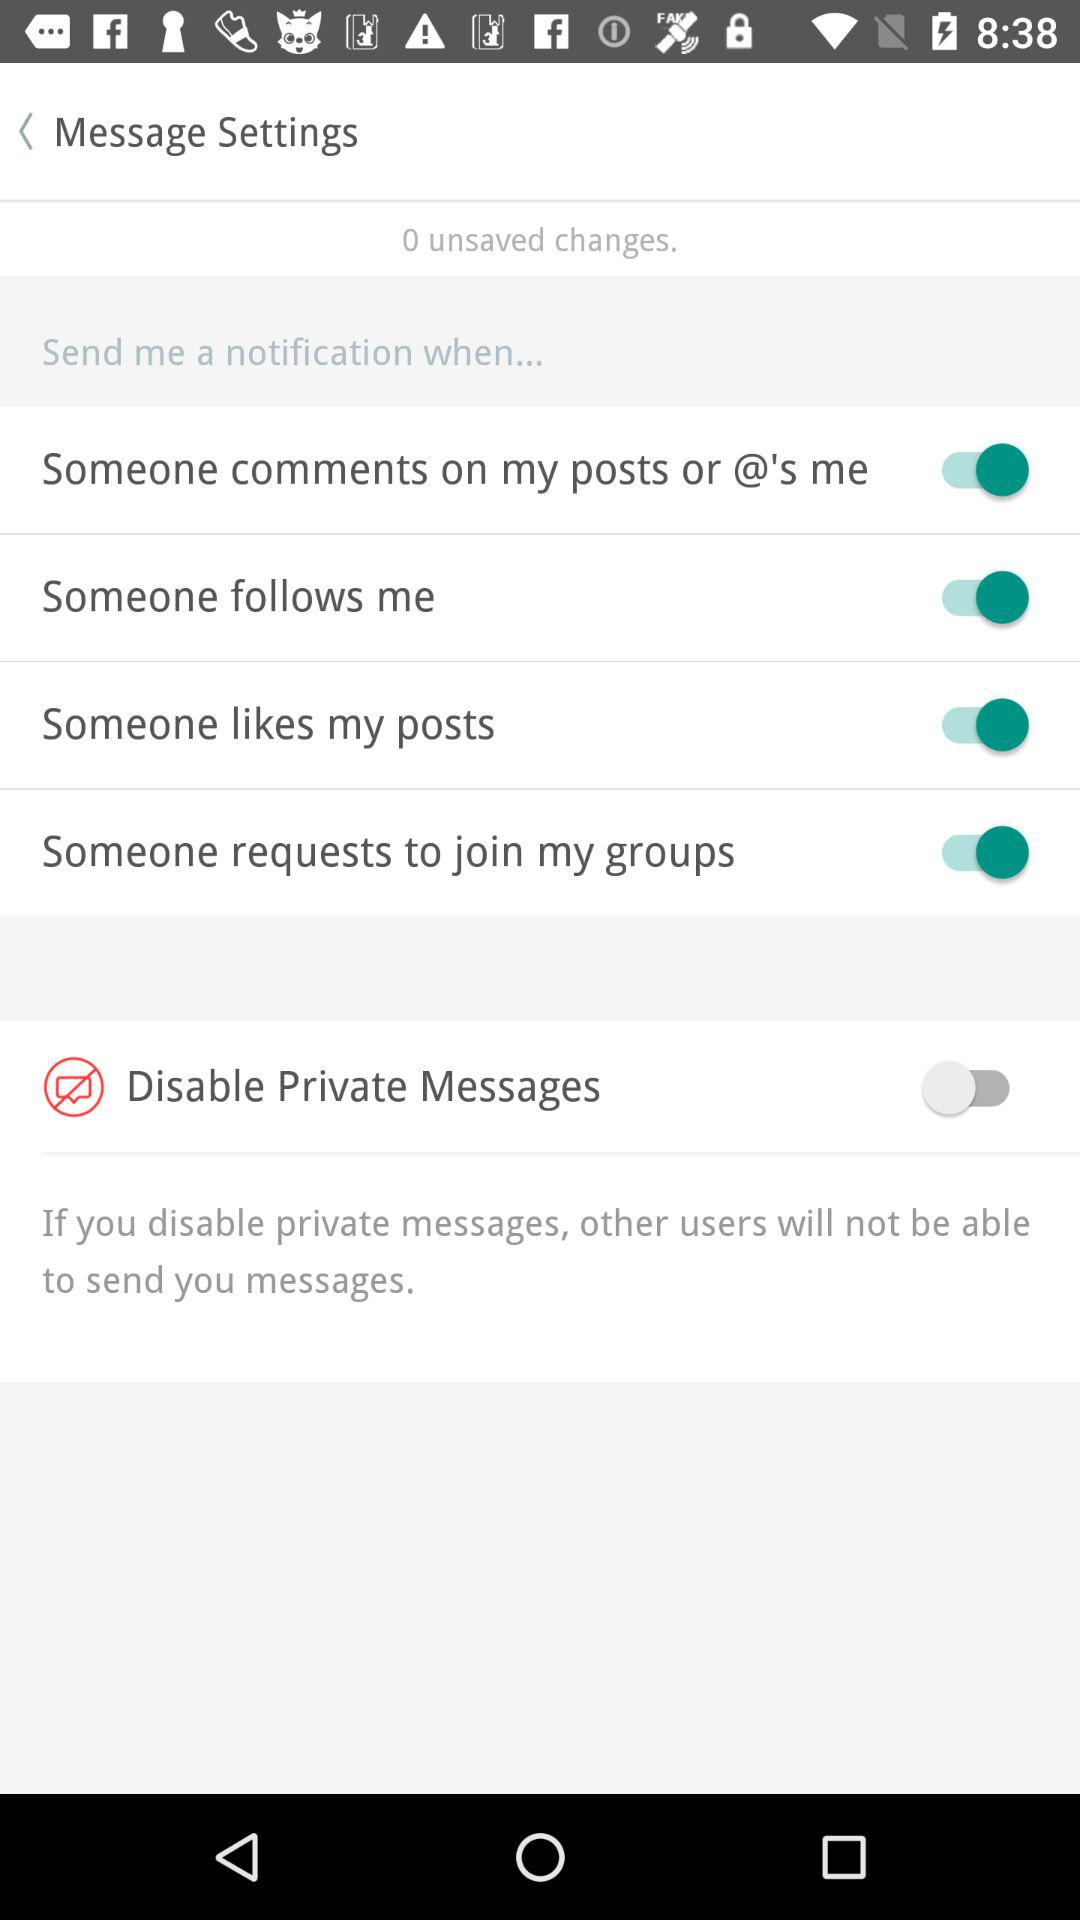What's the status of "Someone follows me"? The status is "on". 